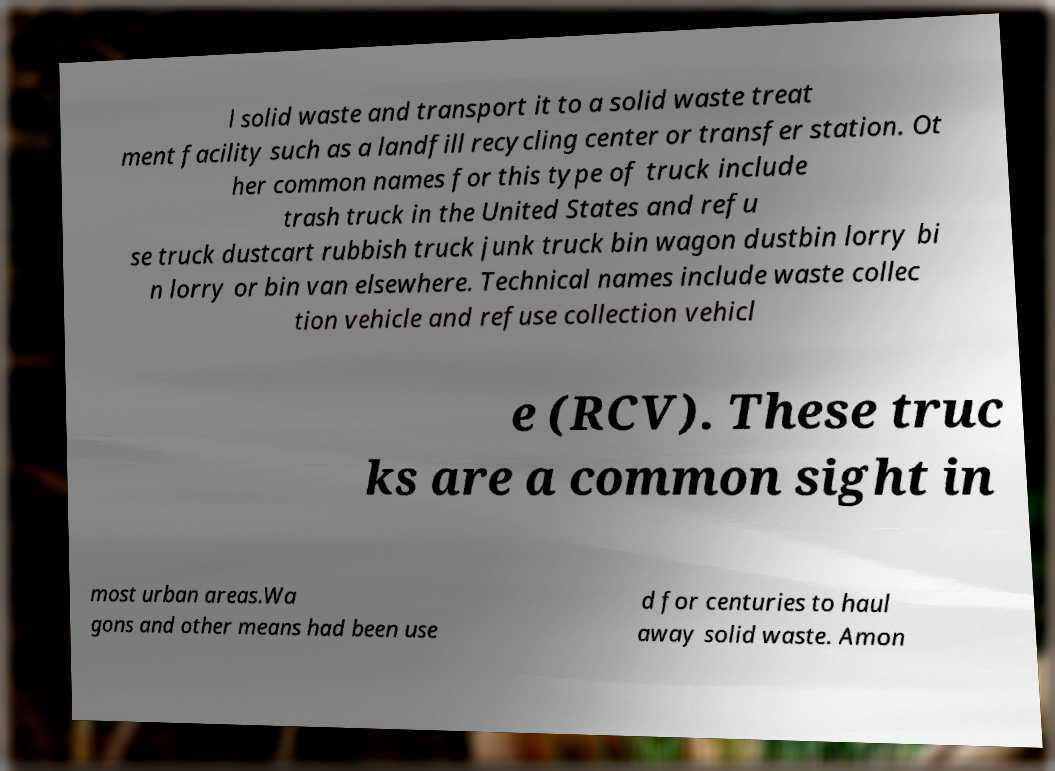What messages or text are displayed in this image? I need them in a readable, typed format. l solid waste and transport it to a solid waste treat ment facility such as a landfill recycling center or transfer station. Ot her common names for this type of truck include trash truck in the United States and refu se truck dustcart rubbish truck junk truck bin wagon dustbin lorry bi n lorry or bin van elsewhere. Technical names include waste collec tion vehicle and refuse collection vehicl e (RCV). These truc ks are a common sight in most urban areas.Wa gons and other means had been use d for centuries to haul away solid waste. Amon 